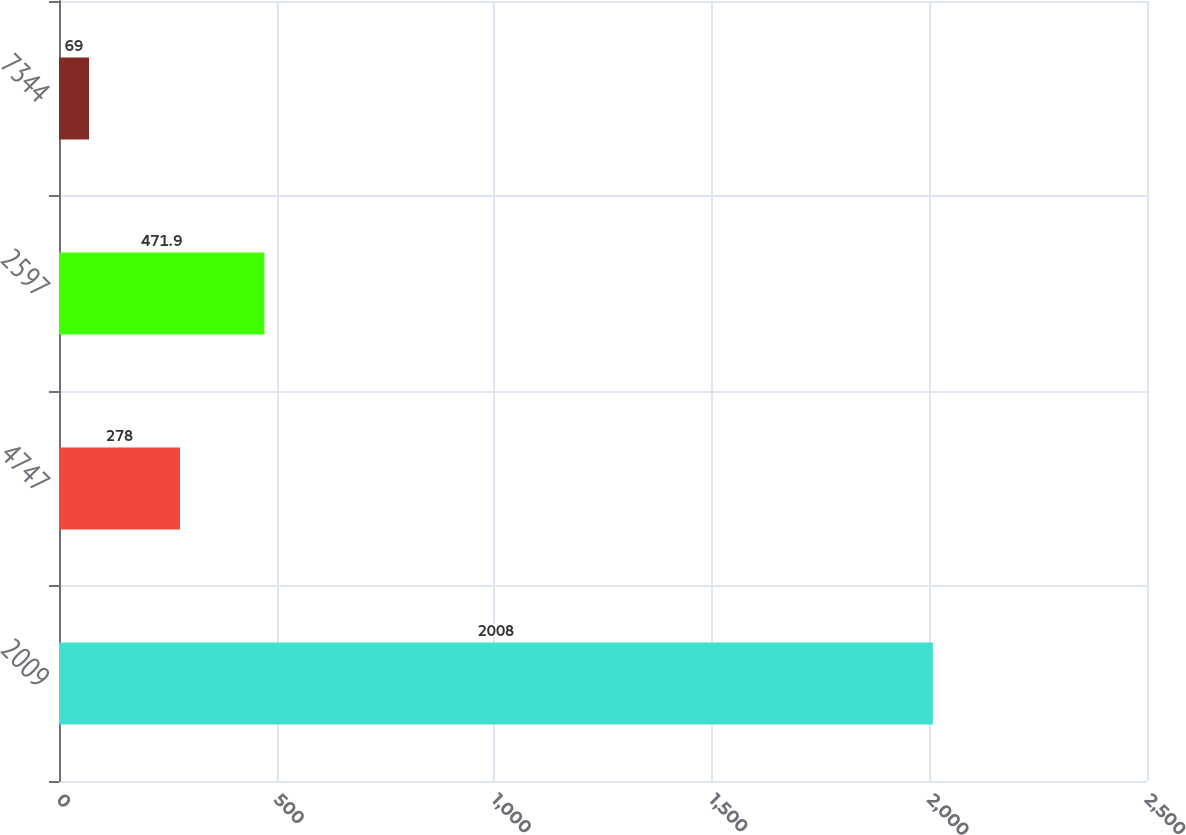Convert chart. <chart><loc_0><loc_0><loc_500><loc_500><bar_chart><fcel>2009<fcel>4747<fcel>2597<fcel>7344<nl><fcel>2008<fcel>278<fcel>471.9<fcel>69<nl></chart> 